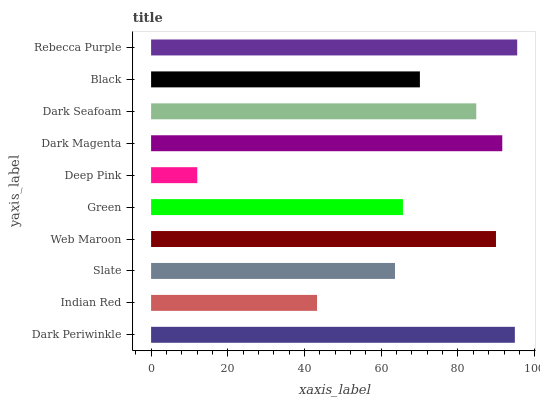Is Deep Pink the minimum?
Answer yes or no. Yes. Is Rebecca Purple the maximum?
Answer yes or no. Yes. Is Indian Red the minimum?
Answer yes or no. No. Is Indian Red the maximum?
Answer yes or no. No. Is Dark Periwinkle greater than Indian Red?
Answer yes or no. Yes. Is Indian Red less than Dark Periwinkle?
Answer yes or no. Yes. Is Indian Red greater than Dark Periwinkle?
Answer yes or no. No. Is Dark Periwinkle less than Indian Red?
Answer yes or no. No. Is Dark Seafoam the high median?
Answer yes or no. Yes. Is Black the low median?
Answer yes or no. Yes. Is Rebecca Purple the high median?
Answer yes or no. No. Is Deep Pink the low median?
Answer yes or no. No. 